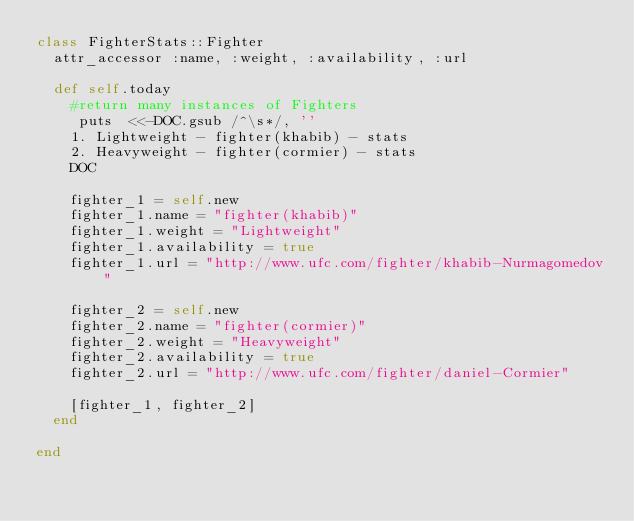Convert code to text. <code><loc_0><loc_0><loc_500><loc_500><_Ruby_>class FighterStats::Fighter
  attr_accessor :name, :weight, :availability, :url
  
  def self.today
    #return many instances of Fighters 
     puts  <<-DOC.gsub /^\s*/, ''
    1. Lightweight - fighter(khabib) - stats  
    2. Heavyweight - fighter(cormier) - stats
    DOC
    
    fighter_1 = self.new
    fighter_1.name = "fighter(khabib)"
    fighter_1.weight = "Lightweight"
    fighter_1.availability = true
    fighter_1.url = "http://www.ufc.com/fighter/khabib-Nurmagomedov"
    
    fighter_2 = self.new
    fighter_2.name = "fighter(cormier)"
    fighter_2.weight = "Heavyweight"
    fighter_2.availability = true
    fighter_2.url = "http://www.ufc.com/fighter/daniel-Cormier"
    
    [fighter_1, fighter_2]
  end
  
end
  </code> 